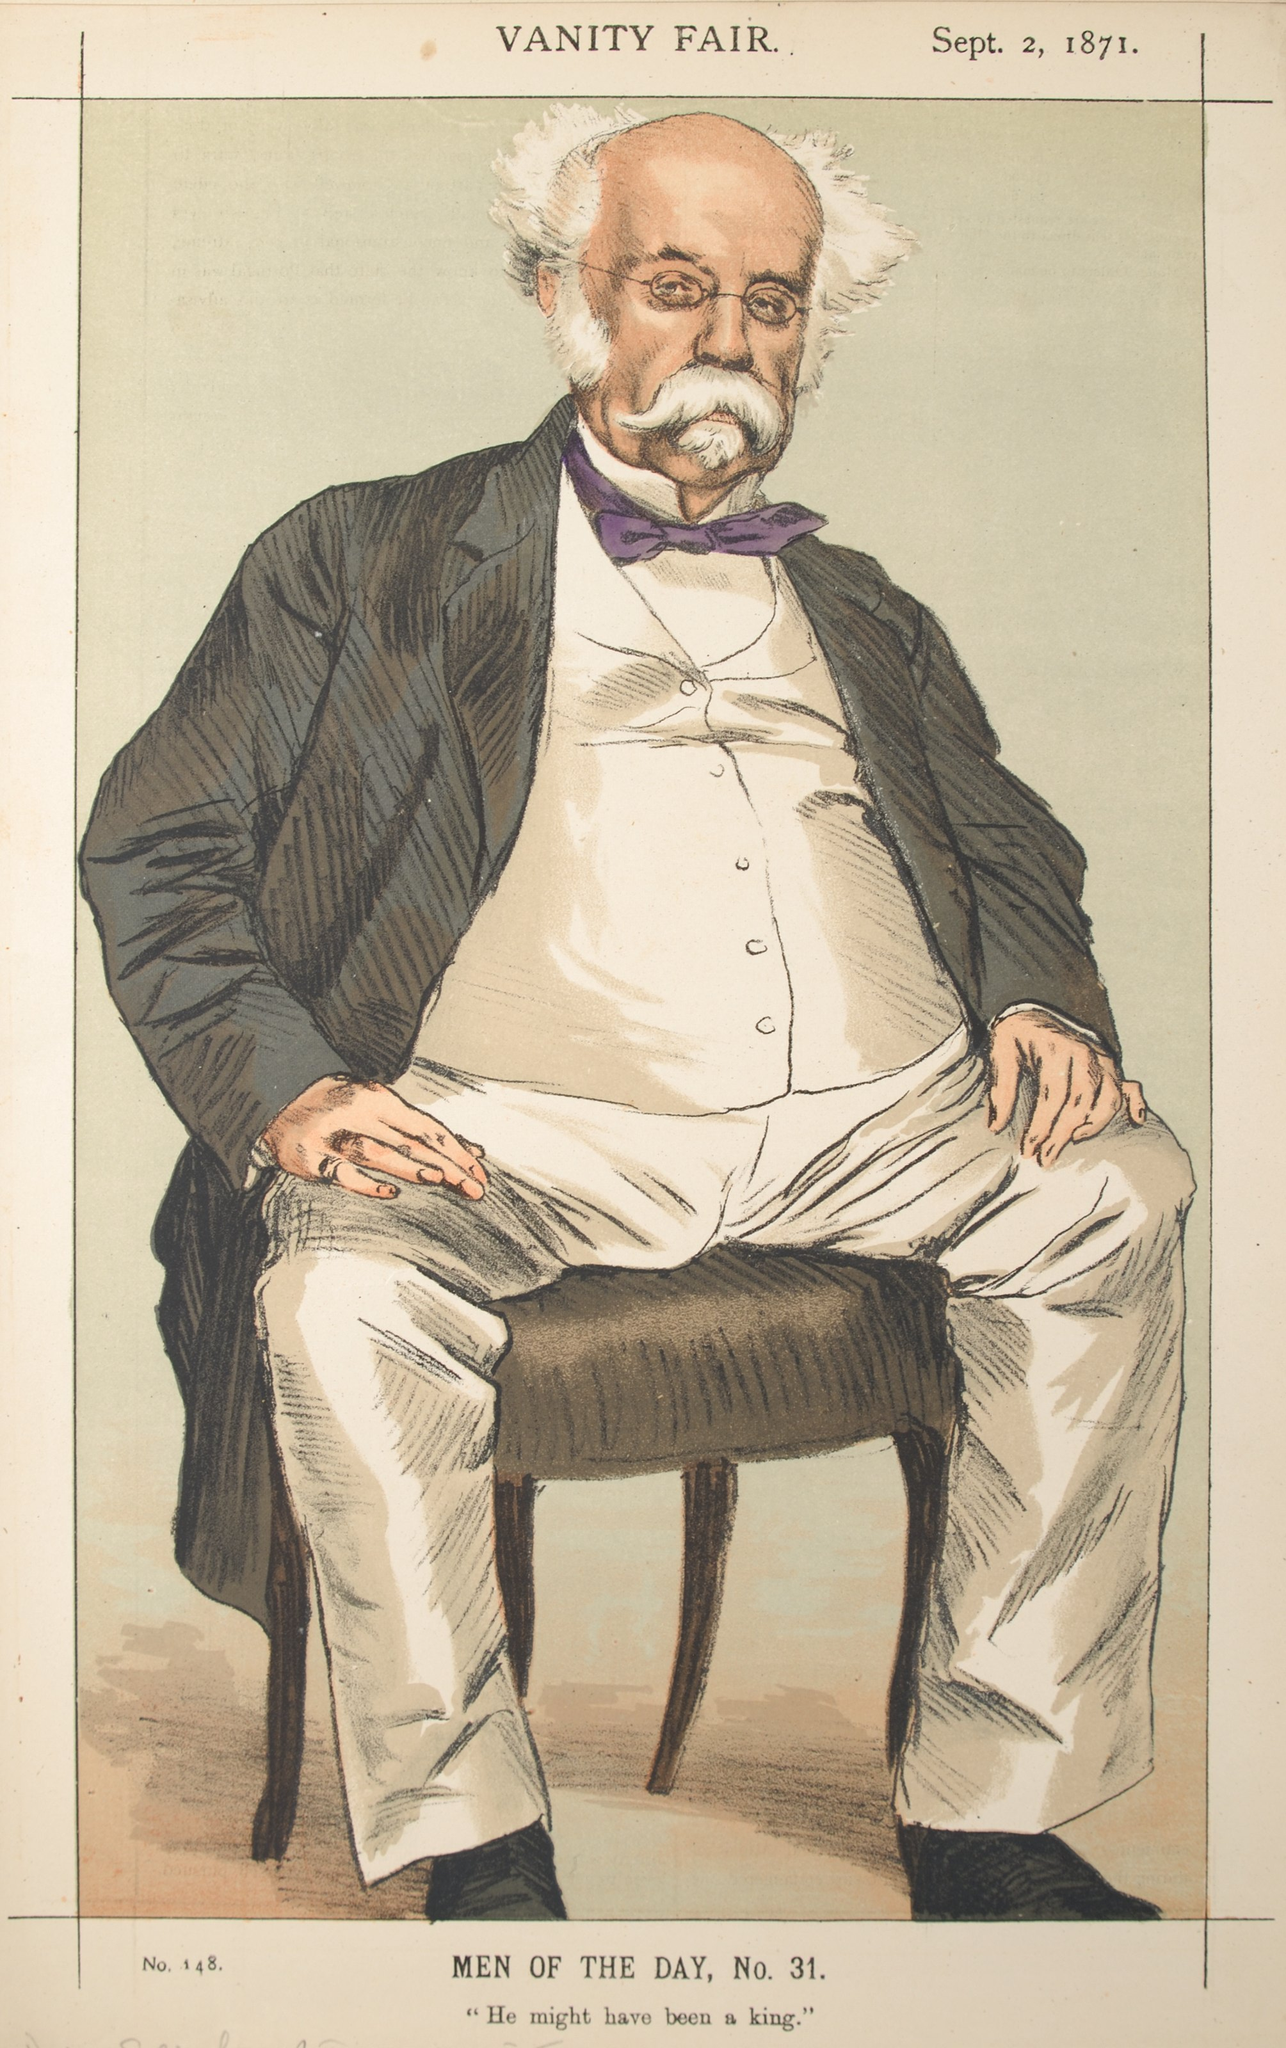This illustration is engaging. Can you tell me a whimsical story about the man in the caricature? In a whimsical twist of fate, the man in the caricature was once a humble tailor named Archibald Stitchwell. Archibald had an extraordinary talent: his stitches were imbued with magic, allowing his clothes to change colors and patterns based on the wearer’s mood. One day, a wandering wizard visited his shop and, impressed by Archibald's skills, granted him a wish. Archibald wished for his creations to be known across the land. Little did he know, the wizard’s magic worked too well! His clothes became so popular that he was thrust into the limelight, adored by nobles and common folk alike. Vanity Fair captured his likeness, forever immortalizing the tailor whose magical stitches brought color and joy to the world. 